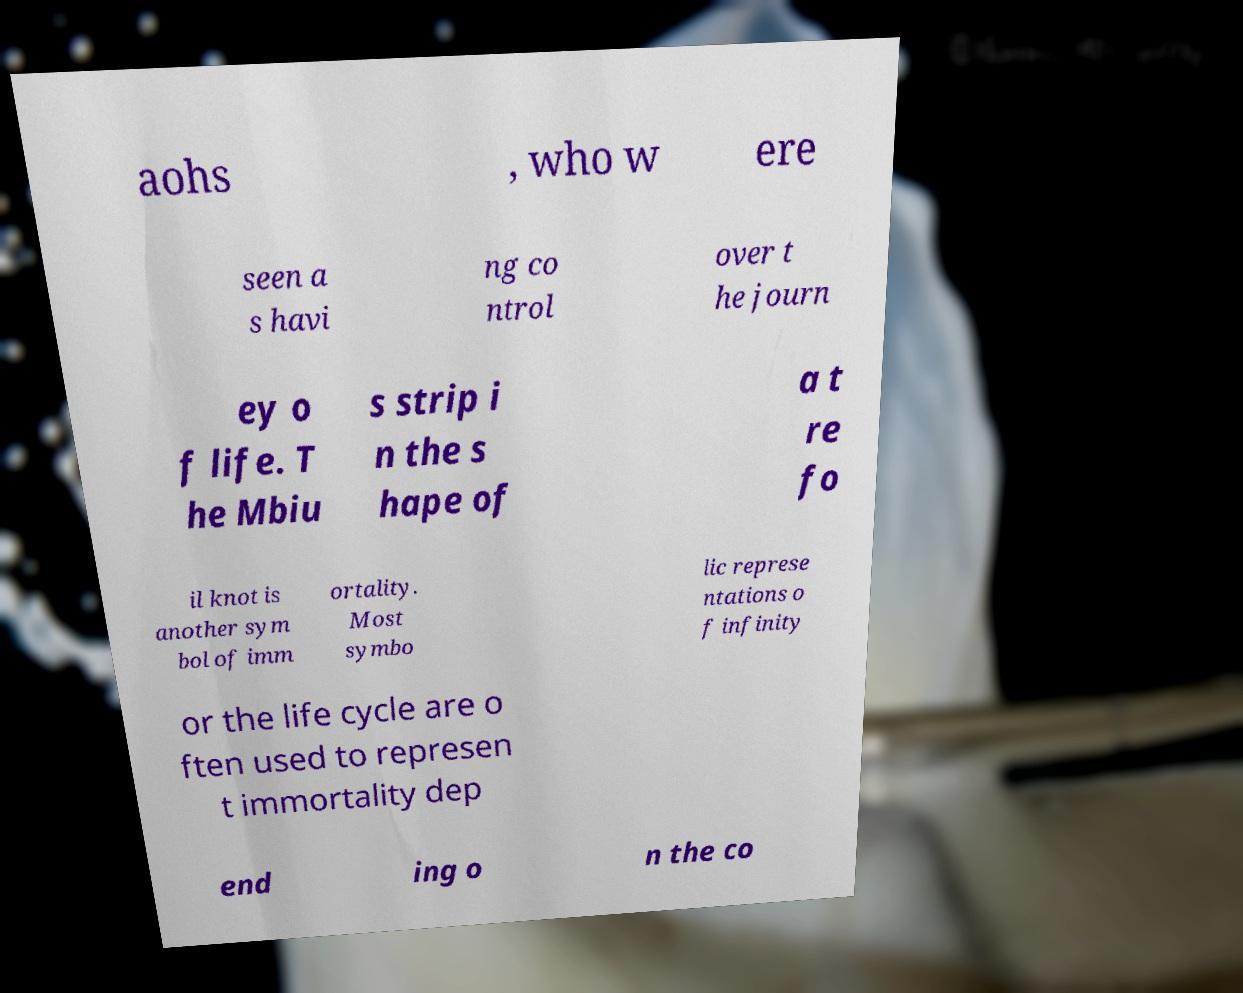Can you accurately transcribe the text from the provided image for me? aohs , who w ere seen a s havi ng co ntrol over t he journ ey o f life. T he Mbiu s strip i n the s hape of a t re fo il knot is another sym bol of imm ortality. Most symbo lic represe ntations o f infinity or the life cycle are o ften used to represen t immortality dep end ing o n the co 